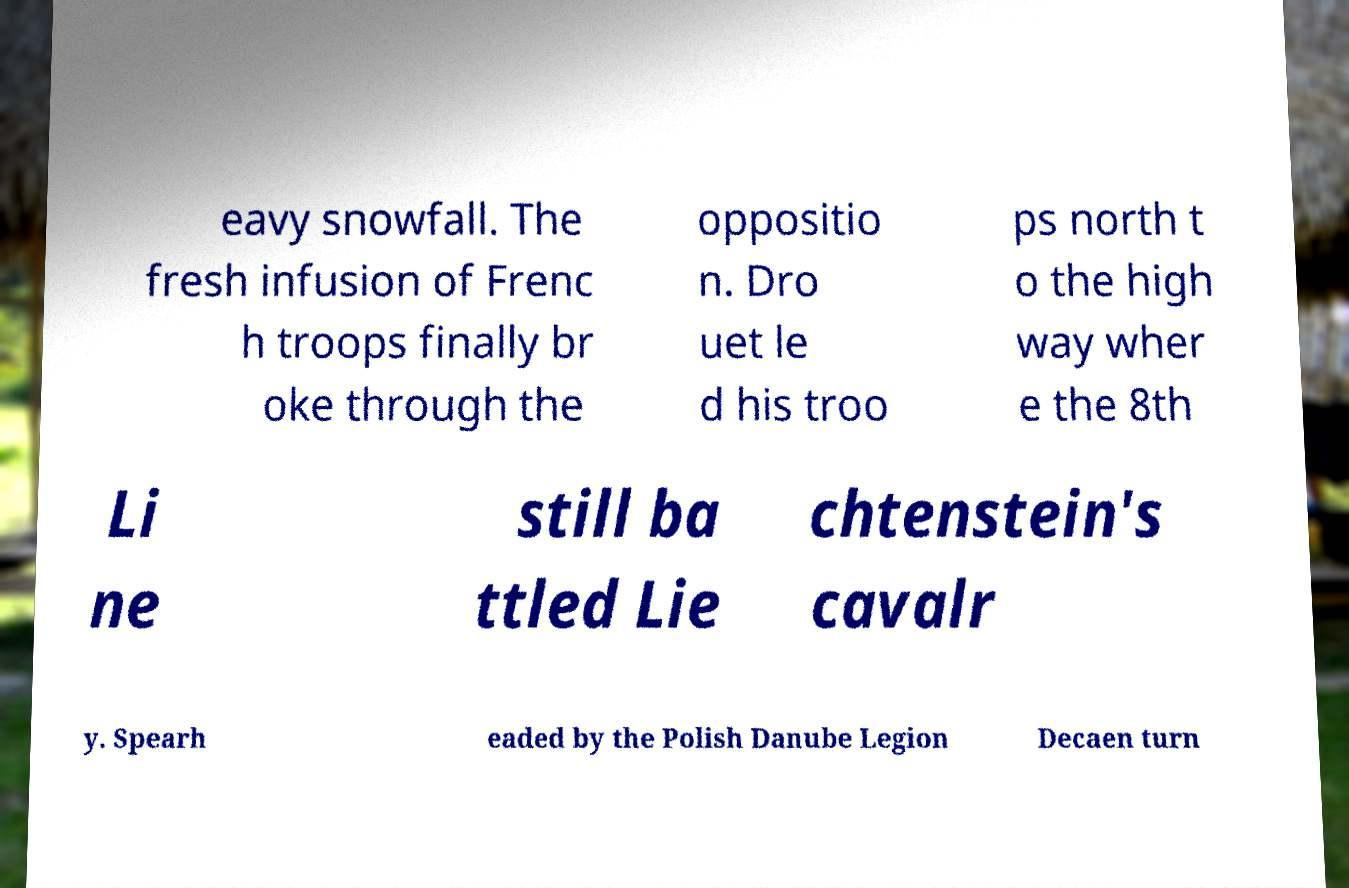Could you assist in decoding the text presented in this image and type it out clearly? eavy snowfall. The fresh infusion of Frenc h troops finally br oke through the oppositio n. Dro uet le d his troo ps north t o the high way wher e the 8th Li ne still ba ttled Lie chtenstein's cavalr y. Spearh eaded by the Polish Danube Legion Decaen turn 